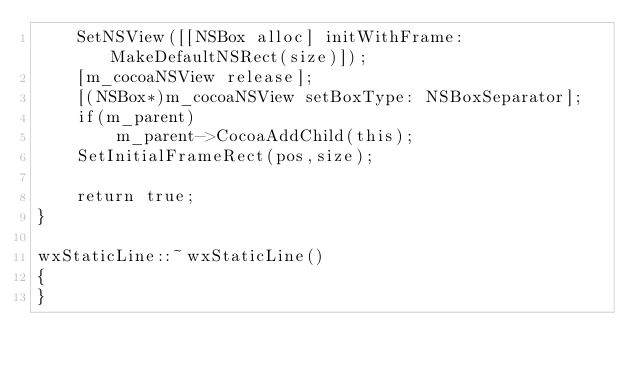<code> <loc_0><loc_0><loc_500><loc_500><_ObjectiveC_>    SetNSView([[NSBox alloc] initWithFrame: MakeDefaultNSRect(size)]);
    [m_cocoaNSView release];
    [(NSBox*)m_cocoaNSView setBoxType: NSBoxSeparator];
    if(m_parent)
        m_parent->CocoaAddChild(this);
    SetInitialFrameRect(pos,size);

    return true;
}

wxStaticLine::~wxStaticLine()
{
}

</code> 